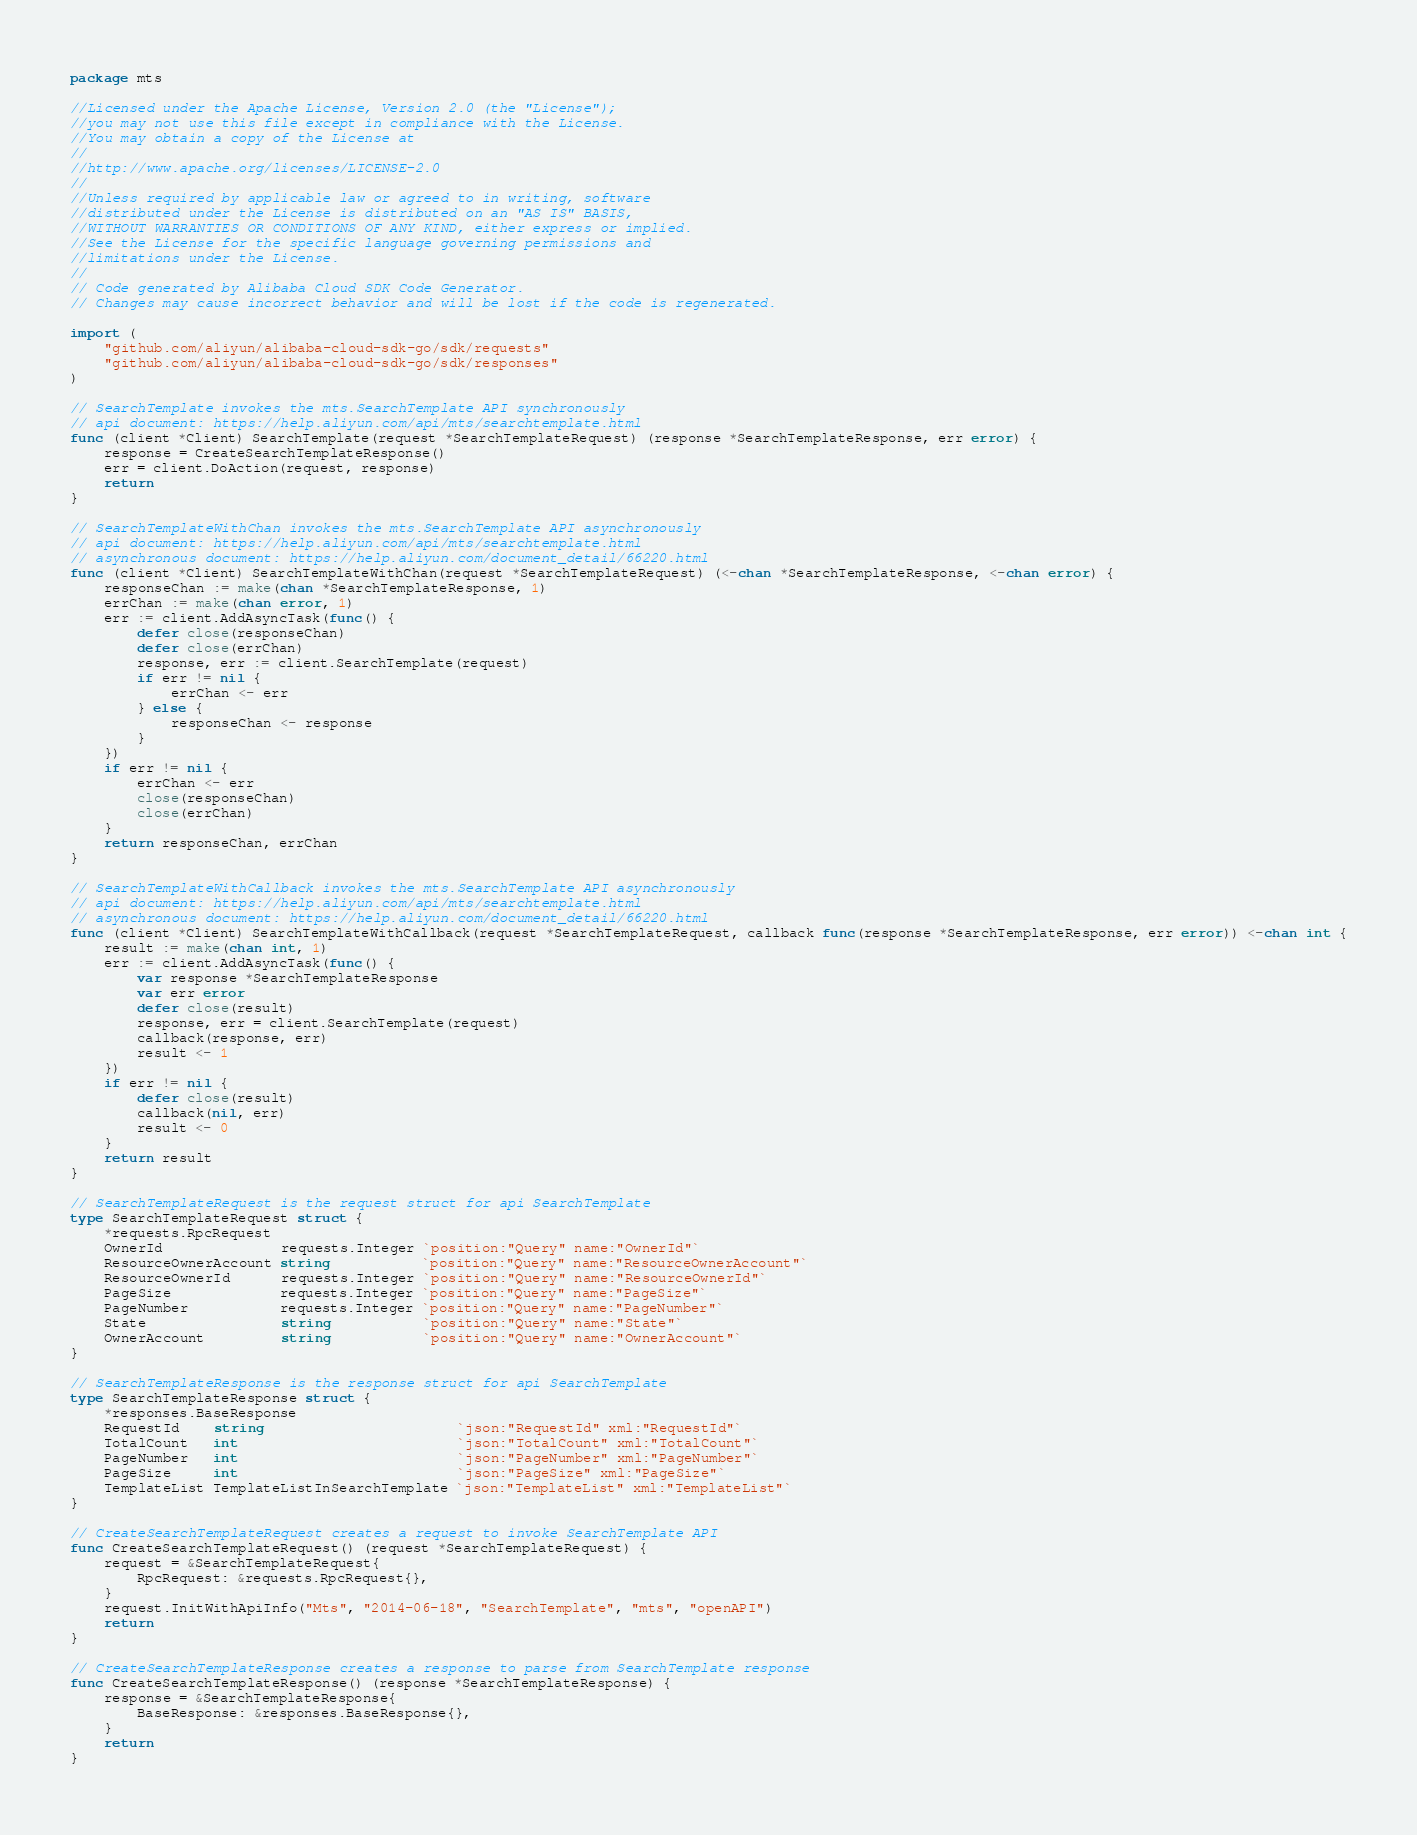<code> <loc_0><loc_0><loc_500><loc_500><_Go_>package mts

//Licensed under the Apache License, Version 2.0 (the "License");
//you may not use this file except in compliance with the License.
//You may obtain a copy of the License at
//
//http://www.apache.org/licenses/LICENSE-2.0
//
//Unless required by applicable law or agreed to in writing, software
//distributed under the License is distributed on an "AS IS" BASIS,
//WITHOUT WARRANTIES OR CONDITIONS OF ANY KIND, either express or implied.
//See the License for the specific language governing permissions and
//limitations under the License.
//
// Code generated by Alibaba Cloud SDK Code Generator.
// Changes may cause incorrect behavior and will be lost if the code is regenerated.

import (
	"github.com/aliyun/alibaba-cloud-sdk-go/sdk/requests"
	"github.com/aliyun/alibaba-cloud-sdk-go/sdk/responses"
)

// SearchTemplate invokes the mts.SearchTemplate API synchronously
// api document: https://help.aliyun.com/api/mts/searchtemplate.html
func (client *Client) SearchTemplate(request *SearchTemplateRequest) (response *SearchTemplateResponse, err error) {
	response = CreateSearchTemplateResponse()
	err = client.DoAction(request, response)
	return
}

// SearchTemplateWithChan invokes the mts.SearchTemplate API asynchronously
// api document: https://help.aliyun.com/api/mts/searchtemplate.html
// asynchronous document: https://help.aliyun.com/document_detail/66220.html
func (client *Client) SearchTemplateWithChan(request *SearchTemplateRequest) (<-chan *SearchTemplateResponse, <-chan error) {
	responseChan := make(chan *SearchTemplateResponse, 1)
	errChan := make(chan error, 1)
	err := client.AddAsyncTask(func() {
		defer close(responseChan)
		defer close(errChan)
		response, err := client.SearchTemplate(request)
		if err != nil {
			errChan <- err
		} else {
			responseChan <- response
		}
	})
	if err != nil {
		errChan <- err
		close(responseChan)
		close(errChan)
	}
	return responseChan, errChan
}

// SearchTemplateWithCallback invokes the mts.SearchTemplate API asynchronously
// api document: https://help.aliyun.com/api/mts/searchtemplate.html
// asynchronous document: https://help.aliyun.com/document_detail/66220.html
func (client *Client) SearchTemplateWithCallback(request *SearchTemplateRequest, callback func(response *SearchTemplateResponse, err error)) <-chan int {
	result := make(chan int, 1)
	err := client.AddAsyncTask(func() {
		var response *SearchTemplateResponse
		var err error
		defer close(result)
		response, err = client.SearchTemplate(request)
		callback(response, err)
		result <- 1
	})
	if err != nil {
		defer close(result)
		callback(nil, err)
		result <- 0
	}
	return result
}

// SearchTemplateRequest is the request struct for api SearchTemplate
type SearchTemplateRequest struct {
	*requests.RpcRequest
	OwnerId              requests.Integer `position:"Query" name:"OwnerId"`
	ResourceOwnerAccount string           `position:"Query" name:"ResourceOwnerAccount"`
	ResourceOwnerId      requests.Integer `position:"Query" name:"ResourceOwnerId"`
	PageSize             requests.Integer `position:"Query" name:"PageSize"`
	PageNumber           requests.Integer `position:"Query" name:"PageNumber"`
	State                string           `position:"Query" name:"State"`
	OwnerAccount         string           `position:"Query" name:"OwnerAccount"`
}

// SearchTemplateResponse is the response struct for api SearchTemplate
type SearchTemplateResponse struct {
	*responses.BaseResponse
	RequestId    string                       `json:"RequestId" xml:"RequestId"`
	TotalCount   int                          `json:"TotalCount" xml:"TotalCount"`
	PageNumber   int                          `json:"PageNumber" xml:"PageNumber"`
	PageSize     int                          `json:"PageSize" xml:"PageSize"`
	TemplateList TemplateListInSearchTemplate `json:"TemplateList" xml:"TemplateList"`
}

// CreateSearchTemplateRequest creates a request to invoke SearchTemplate API
func CreateSearchTemplateRequest() (request *SearchTemplateRequest) {
	request = &SearchTemplateRequest{
		RpcRequest: &requests.RpcRequest{},
	}
	request.InitWithApiInfo("Mts", "2014-06-18", "SearchTemplate", "mts", "openAPI")
	return
}

// CreateSearchTemplateResponse creates a response to parse from SearchTemplate response
func CreateSearchTemplateResponse() (response *SearchTemplateResponse) {
	response = &SearchTemplateResponse{
		BaseResponse: &responses.BaseResponse{},
	}
	return
}
</code> 